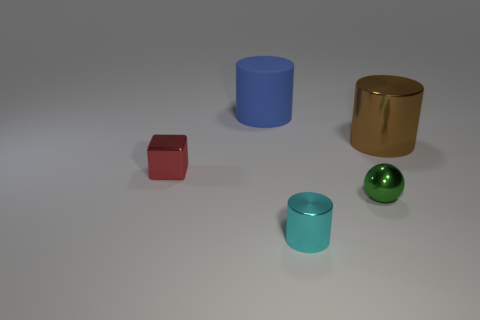Subtract all cyan spheres. Subtract all red cubes. How many spheres are left? 1 Add 3 big blue rubber objects. How many objects exist? 8 Subtract all spheres. How many objects are left? 4 Add 4 tiny shiny cubes. How many tiny shiny cubes exist? 5 Subtract 1 cyan cylinders. How many objects are left? 4 Subtract all large yellow rubber cylinders. Subtract all small red cubes. How many objects are left? 4 Add 5 small blocks. How many small blocks are left? 6 